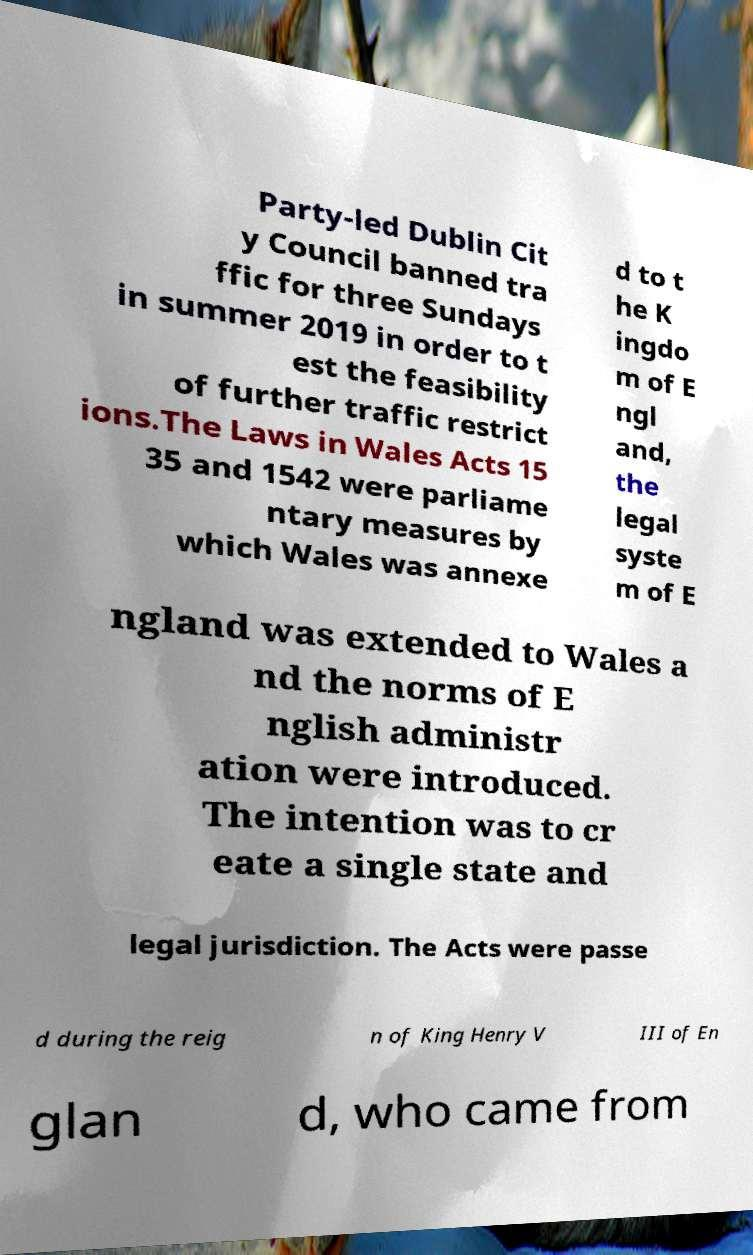Can you read and provide the text displayed in the image?This photo seems to have some interesting text. Can you extract and type it out for me? Party-led Dublin Cit y Council banned tra ffic for three Sundays in summer 2019 in order to t est the feasibility of further traffic restrict ions.The Laws in Wales Acts 15 35 and 1542 were parliame ntary measures by which Wales was annexe d to t he K ingdo m of E ngl and, the legal syste m of E ngland was extended to Wales a nd the norms of E nglish administr ation were introduced. The intention was to cr eate a single state and legal jurisdiction. The Acts were passe d during the reig n of King Henry V III of En glan d, who came from 